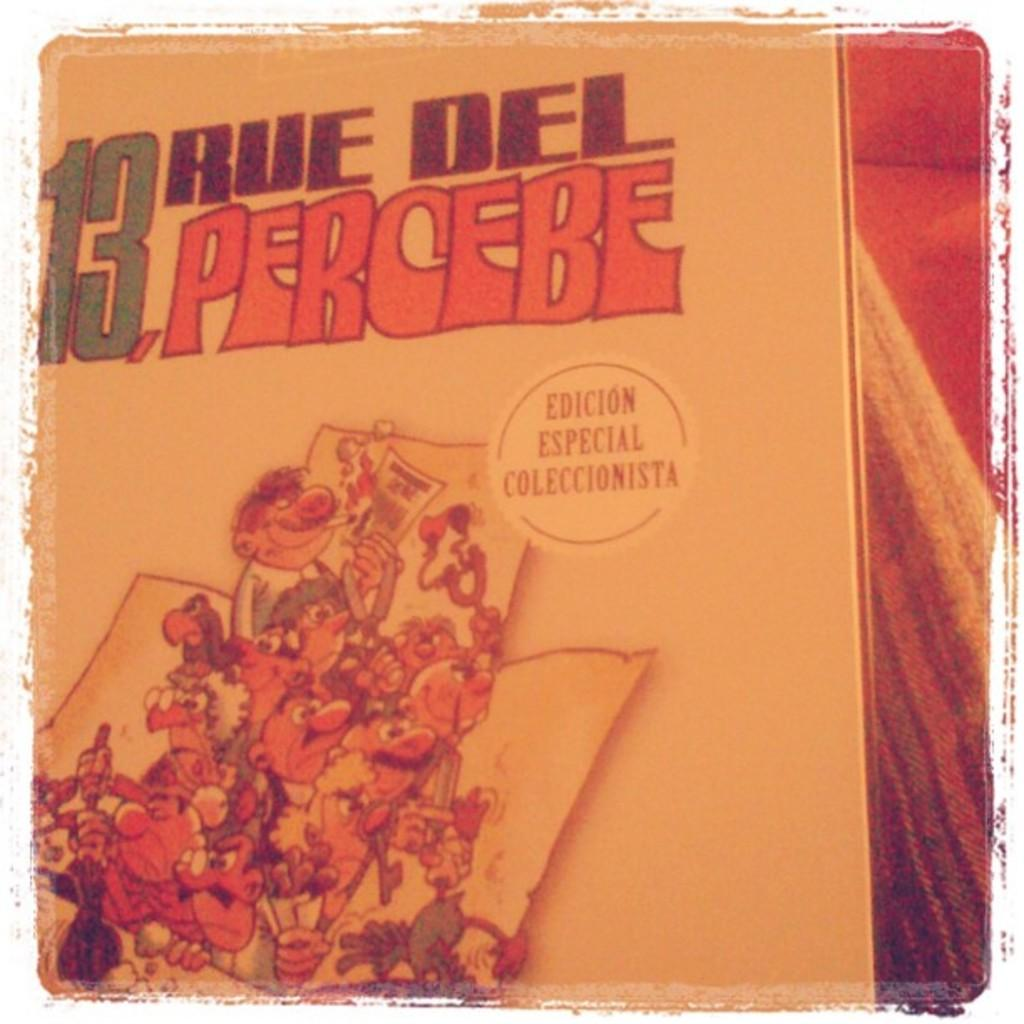<image>
Relay a brief, clear account of the picture shown. A book with colorful illustrations of people is indicated as a special edition. 